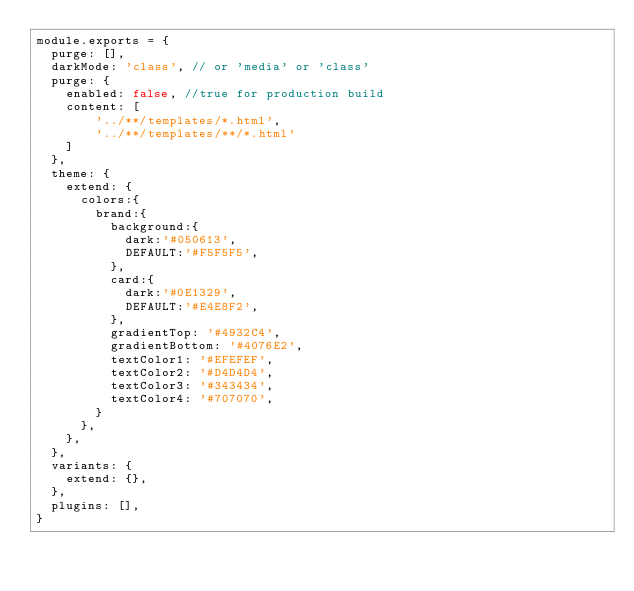<code> <loc_0><loc_0><loc_500><loc_500><_JavaScript_>module.exports = {
  purge: [],
  darkMode: 'class', // or 'media' or 'class'
  purge: {
    enabled: false, //true for production build
    content: [
        '../**/templates/*.html',
        '../**/templates/**/*.html'
    ]
  },
  theme: {
    extend: {
      colors:{
        brand:{
          background:{
            dark:'#050613',
            DEFAULT:'#F5F5F5',
          },
          card:{
            dark:'#0E1329',
            DEFAULT:'#E4E8F2',
          },
          gradientTop: '#4932C4',
          gradientBottom: '#4076E2',
          textColor1: '#EFEFEF',
          textColor2: '#D4D4D4',
          textColor3: '#343434',
          textColor4: '#707070',
        }
      },
    },
  },
  variants: {
    extend: {},
  },
  plugins: [],
}
</code> 